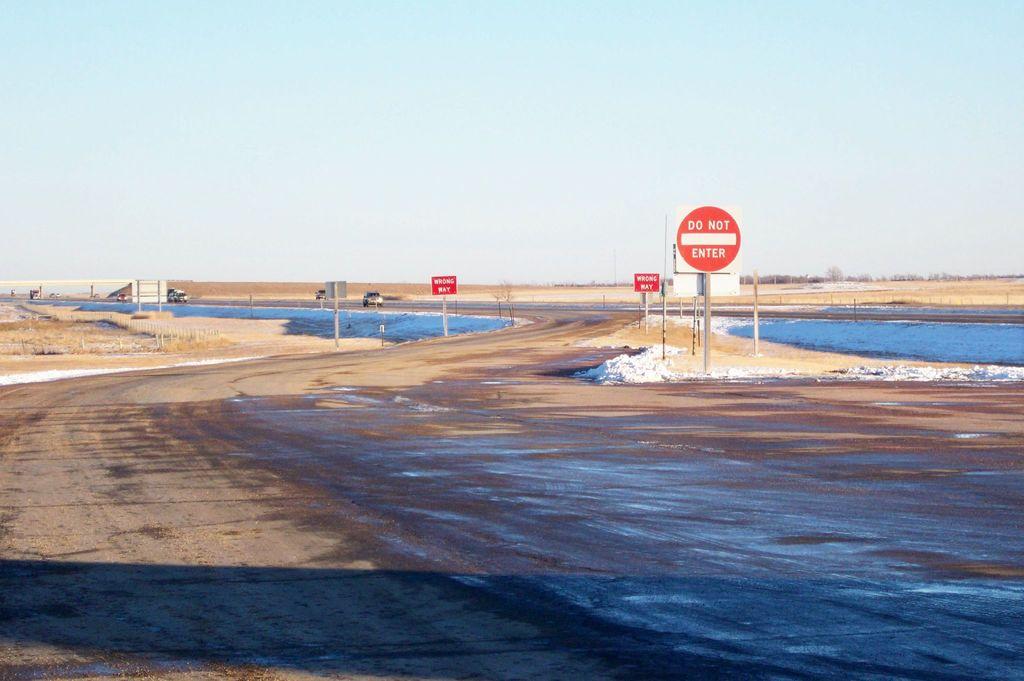What do the small red signs say?
Your response must be concise. Wrong way. 